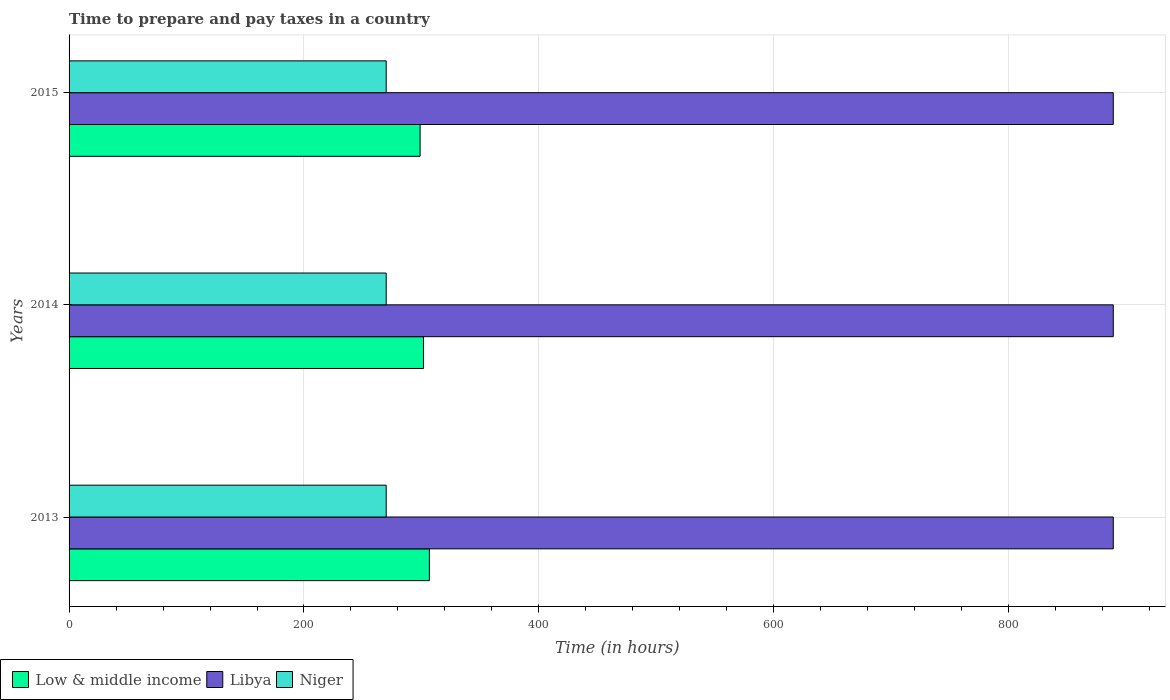How many groups of bars are there?
Your answer should be very brief. 3. What is the number of hours required to prepare and pay taxes in Libya in 2014?
Your response must be concise. 889. Across all years, what is the maximum number of hours required to prepare and pay taxes in Niger?
Ensure brevity in your answer.  270. Across all years, what is the minimum number of hours required to prepare and pay taxes in Niger?
Make the answer very short. 270. In which year was the number of hours required to prepare and pay taxes in Niger maximum?
Offer a terse response. 2013. In which year was the number of hours required to prepare and pay taxes in Low & middle income minimum?
Make the answer very short. 2015. What is the total number of hours required to prepare and pay taxes in Niger in the graph?
Offer a terse response. 810. What is the difference between the number of hours required to prepare and pay taxes in Niger in 2013 and that in 2015?
Keep it short and to the point. 0. What is the difference between the number of hours required to prepare and pay taxes in Low & middle income in 2014 and the number of hours required to prepare and pay taxes in Libya in 2013?
Offer a very short reply. -587.22. What is the average number of hours required to prepare and pay taxes in Low & middle income per year?
Provide a short and direct response. 302.46. In the year 2013, what is the difference between the number of hours required to prepare and pay taxes in Niger and number of hours required to prepare and pay taxes in Libya?
Offer a terse response. -619. In how many years, is the number of hours required to prepare and pay taxes in Low & middle income greater than 520 hours?
Keep it short and to the point. 0. What is the ratio of the number of hours required to prepare and pay taxes in Low & middle income in 2014 to that in 2015?
Your response must be concise. 1.01. Is the number of hours required to prepare and pay taxes in Niger in 2013 less than that in 2014?
Your answer should be compact. No. What is the difference between the highest and the lowest number of hours required to prepare and pay taxes in Low & middle income?
Your response must be concise. 7.88. In how many years, is the number of hours required to prepare and pay taxes in Libya greater than the average number of hours required to prepare and pay taxes in Libya taken over all years?
Your response must be concise. 0. What does the 2nd bar from the top in 2015 represents?
Ensure brevity in your answer.  Libya. Is it the case that in every year, the sum of the number of hours required to prepare and pay taxes in Libya and number of hours required to prepare and pay taxes in Niger is greater than the number of hours required to prepare and pay taxes in Low & middle income?
Provide a short and direct response. Yes. Are all the bars in the graph horizontal?
Provide a succinct answer. Yes. What is the difference between two consecutive major ticks on the X-axis?
Provide a short and direct response. 200. Does the graph contain grids?
Give a very brief answer. Yes. Where does the legend appear in the graph?
Ensure brevity in your answer.  Bottom left. What is the title of the graph?
Ensure brevity in your answer.  Time to prepare and pay taxes in a country. Does "Austria" appear as one of the legend labels in the graph?
Ensure brevity in your answer.  No. What is the label or title of the X-axis?
Offer a very short reply. Time (in hours). What is the Time (in hours) in Low & middle income in 2013?
Ensure brevity in your answer.  306.74. What is the Time (in hours) of Libya in 2013?
Provide a succinct answer. 889. What is the Time (in hours) in Niger in 2013?
Your answer should be very brief. 270. What is the Time (in hours) in Low & middle income in 2014?
Provide a short and direct response. 301.78. What is the Time (in hours) in Libya in 2014?
Provide a short and direct response. 889. What is the Time (in hours) in Niger in 2014?
Make the answer very short. 270. What is the Time (in hours) of Low & middle income in 2015?
Make the answer very short. 298.87. What is the Time (in hours) in Libya in 2015?
Offer a terse response. 889. What is the Time (in hours) of Niger in 2015?
Your response must be concise. 270. Across all years, what is the maximum Time (in hours) of Low & middle income?
Your response must be concise. 306.74. Across all years, what is the maximum Time (in hours) in Libya?
Keep it short and to the point. 889. Across all years, what is the maximum Time (in hours) of Niger?
Give a very brief answer. 270. Across all years, what is the minimum Time (in hours) of Low & middle income?
Your response must be concise. 298.87. Across all years, what is the minimum Time (in hours) of Libya?
Provide a short and direct response. 889. Across all years, what is the minimum Time (in hours) in Niger?
Keep it short and to the point. 270. What is the total Time (in hours) in Low & middle income in the graph?
Offer a very short reply. 907.39. What is the total Time (in hours) of Libya in the graph?
Your answer should be very brief. 2667. What is the total Time (in hours) of Niger in the graph?
Keep it short and to the point. 810. What is the difference between the Time (in hours) of Low & middle income in 2013 and that in 2014?
Your answer should be compact. 4.97. What is the difference between the Time (in hours) of Libya in 2013 and that in 2014?
Offer a terse response. 0. What is the difference between the Time (in hours) in Niger in 2013 and that in 2014?
Your response must be concise. 0. What is the difference between the Time (in hours) of Low & middle income in 2013 and that in 2015?
Your answer should be very brief. 7.88. What is the difference between the Time (in hours) of Libya in 2013 and that in 2015?
Provide a succinct answer. 0. What is the difference between the Time (in hours) in Low & middle income in 2014 and that in 2015?
Your answer should be compact. 2.91. What is the difference between the Time (in hours) in Low & middle income in 2013 and the Time (in hours) in Libya in 2014?
Your answer should be very brief. -582.26. What is the difference between the Time (in hours) in Low & middle income in 2013 and the Time (in hours) in Niger in 2014?
Your response must be concise. 36.74. What is the difference between the Time (in hours) in Libya in 2013 and the Time (in hours) in Niger in 2014?
Offer a very short reply. 619. What is the difference between the Time (in hours) in Low & middle income in 2013 and the Time (in hours) in Libya in 2015?
Ensure brevity in your answer.  -582.26. What is the difference between the Time (in hours) in Low & middle income in 2013 and the Time (in hours) in Niger in 2015?
Your answer should be compact. 36.74. What is the difference between the Time (in hours) in Libya in 2013 and the Time (in hours) in Niger in 2015?
Keep it short and to the point. 619. What is the difference between the Time (in hours) in Low & middle income in 2014 and the Time (in hours) in Libya in 2015?
Provide a short and direct response. -587.22. What is the difference between the Time (in hours) in Low & middle income in 2014 and the Time (in hours) in Niger in 2015?
Offer a very short reply. 31.78. What is the difference between the Time (in hours) of Libya in 2014 and the Time (in hours) of Niger in 2015?
Your answer should be very brief. 619. What is the average Time (in hours) of Low & middle income per year?
Your answer should be compact. 302.46. What is the average Time (in hours) in Libya per year?
Give a very brief answer. 889. What is the average Time (in hours) of Niger per year?
Your answer should be very brief. 270. In the year 2013, what is the difference between the Time (in hours) of Low & middle income and Time (in hours) of Libya?
Offer a very short reply. -582.26. In the year 2013, what is the difference between the Time (in hours) in Low & middle income and Time (in hours) in Niger?
Your answer should be compact. 36.74. In the year 2013, what is the difference between the Time (in hours) in Libya and Time (in hours) in Niger?
Give a very brief answer. 619. In the year 2014, what is the difference between the Time (in hours) of Low & middle income and Time (in hours) of Libya?
Keep it short and to the point. -587.22. In the year 2014, what is the difference between the Time (in hours) of Low & middle income and Time (in hours) of Niger?
Give a very brief answer. 31.78. In the year 2014, what is the difference between the Time (in hours) of Libya and Time (in hours) of Niger?
Offer a terse response. 619. In the year 2015, what is the difference between the Time (in hours) in Low & middle income and Time (in hours) in Libya?
Give a very brief answer. -590.13. In the year 2015, what is the difference between the Time (in hours) of Low & middle income and Time (in hours) of Niger?
Keep it short and to the point. 28.87. In the year 2015, what is the difference between the Time (in hours) of Libya and Time (in hours) of Niger?
Make the answer very short. 619. What is the ratio of the Time (in hours) in Low & middle income in 2013 to that in 2014?
Your response must be concise. 1.02. What is the ratio of the Time (in hours) of Niger in 2013 to that in 2014?
Ensure brevity in your answer.  1. What is the ratio of the Time (in hours) in Low & middle income in 2013 to that in 2015?
Provide a succinct answer. 1.03. What is the ratio of the Time (in hours) of Niger in 2013 to that in 2015?
Offer a very short reply. 1. What is the ratio of the Time (in hours) of Low & middle income in 2014 to that in 2015?
Offer a terse response. 1.01. What is the ratio of the Time (in hours) in Libya in 2014 to that in 2015?
Give a very brief answer. 1. What is the ratio of the Time (in hours) of Niger in 2014 to that in 2015?
Provide a short and direct response. 1. What is the difference between the highest and the second highest Time (in hours) in Low & middle income?
Offer a very short reply. 4.97. What is the difference between the highest and the second highest Time (in hours) of Niger?
Your response must be concise. 0. What is the difference between the highest and the lowest Time (in hours) of Low & middle income?
Provide a short and direct response. 7.88. What is the difference between the highest and the lowest Time (in hours) of Niger?
Provide a succinct answer. 0. 